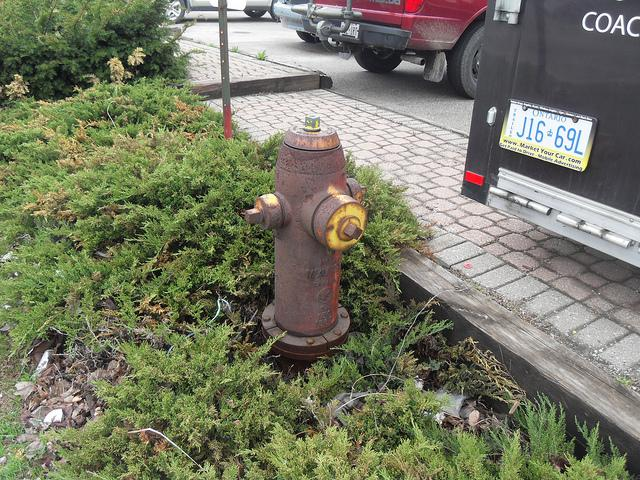Where is the fire hydrant mounted? grass 